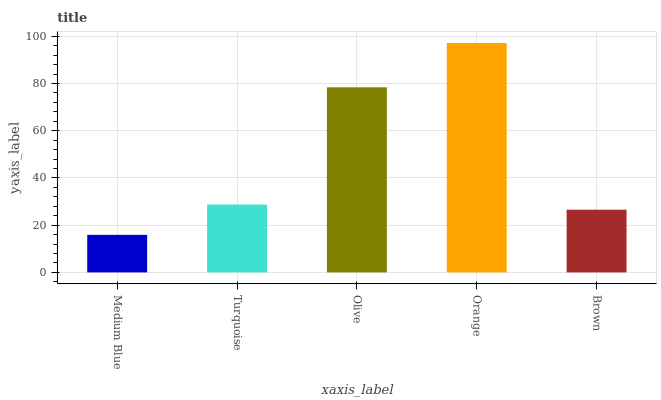Is Medium Blue the minimum?
Answer yes or no. Yes. Is Orange the maximum?
Answer yes or no. Yes. Is Turquoise the minimum?
Answer yes or no. No. Is Turquoise the maximum?
Answer yes or no. No. Is Turquoise greater than Medium Blue?
Answer yes or no. Yes. Is Medium Blue less than Turquoise?
Answer yes or no. Yes. Is Medium Blue greater than Turquoise?
Answer yes or no. No. Is Turquoise less than Medium Blue?
Answer yes or no. No. Is Turquoise the high median?
Answer yes or no. Yes. Is Turquoise the low median?
Answer yes or no. Yes. Is Orange the high median?
Answer yes or no. No. Is Olive the low median?
Answer yes or no. No. 